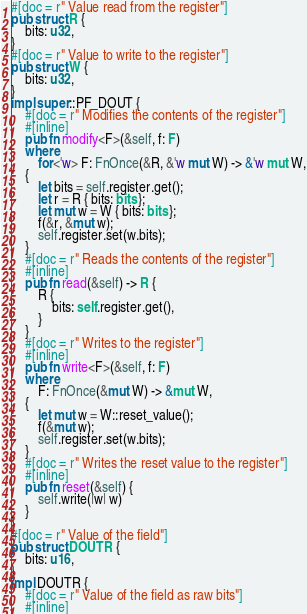<code> <loc_0><loc_0><loc_500><loc_500><_Rust_>#[doc = r" Value read from the register"]
pub struct R {
    bits: u32,
}
#[doc = r" Value to write to the register"]
pub struct W {
    bits: u32,
}
impl super::PF_DOUT {
    #[doc = r" Modifies the contents of the register"]
    #[inline]
    pub fn modify<F>(&self, f: F)
    where
        for<'w> F: FnOnce(&R, &'w mut W) -> &'w mut W,
    {
        let bits = self.register.get();
        let r = R { bits: bits };
        let mut w = W { bits: bits };
        f(&r, &mut w);
        self.register.set(w.bits);
    }
    #[doc = r" Reads the contents of the register"]
    #[inline]
    pub fn read(&self) -> R {
        R {
            bits: self.register.get(),
        }
    }
    #[doc = r" Writes to the register"]
    #[inline]
    pub fn write<F>(&self, f: F)
    where
        F: FnOnce(&mut W) -> &mut W,
    {
        let mut w = W::reset_value();
        f(&mut w);
        self.register.set(w.bits);
    }
    #[doc = r" Writes the reset value to the register"]
    #[inline]
    pub fn reset(&self) {
        self.write(|w| w)
    }
}
#[doc = r" Value of the field"]
pub struct DOUTR {
    bits: u16,
}
impl DOUTR {
    #[doc = r" Value of the field as raw bits"]
    #[inline]</code> 